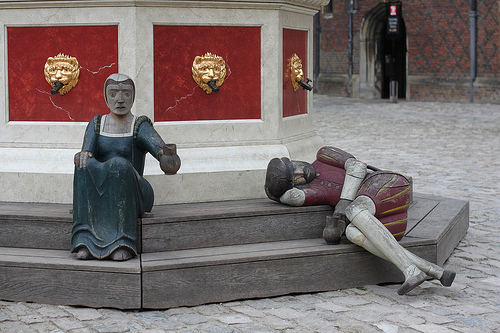<image>
Can you confirm if the sign is behind the statue? Yes. From this viewpoint, the sign is positioned behind the statue, with the statue partially or fully occluding the sign. Is there a statue behind the steps? No. The statue is not behind the steps. From this viewpoint, the statue appears to be positioned elsewhere in the scene. 